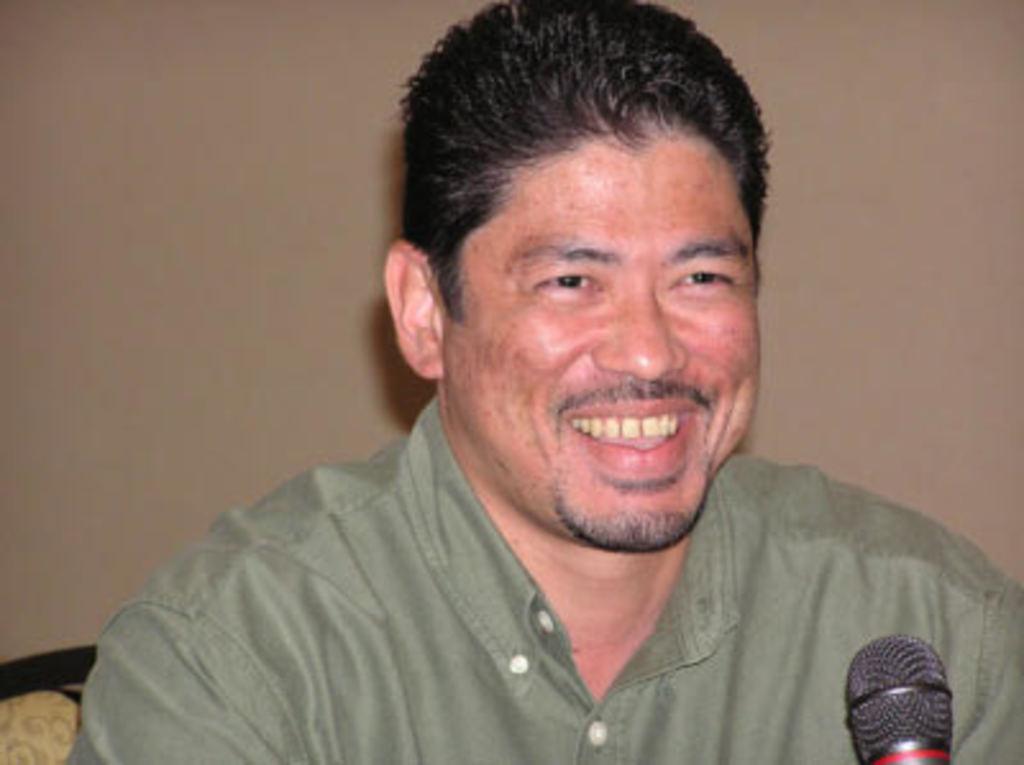Describe this image in one or two sentences. In this image I can see the person is smiling and wearing green color dress. I can see the mic. Background is in brown color. 